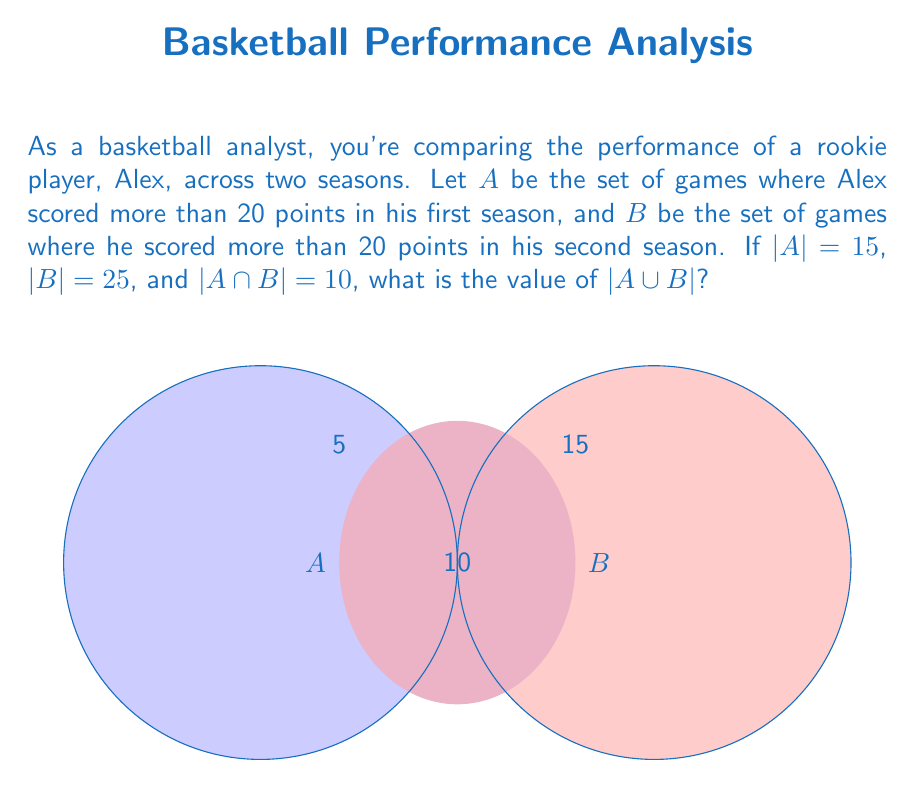Help me with this question. Let's approach this step-by-step using set theory:

1) We are given:
   |A| = 15 (games with >20 points in first season)
   |B| = 25 (games with >20 points in second season)
   |A ∩ B| = 10 (games with >20 points in both seasons)

2) We need to find |A ∪ B|, which is the total number of games where Alex scored more than 20 points in either season.

3) We can use the inclusion-exclusion principle:
   |A ∪ B| = |A| + |B| - |A ∩ B|

4) This principle works because if we simply add |A| and |B|, we would be counting the elements in A ∩ B twice, so we need to subtract |A ∩ B| once.

5) Substituting the values:
   |A ∪ B| = 15 + 25 - 10

6) Calculating:
   |A ∪ B| = 40 - 10 = 30

Therefore, there are 30 games in total where Alex scored more than 20 points across both seasons.
Answer: 30 